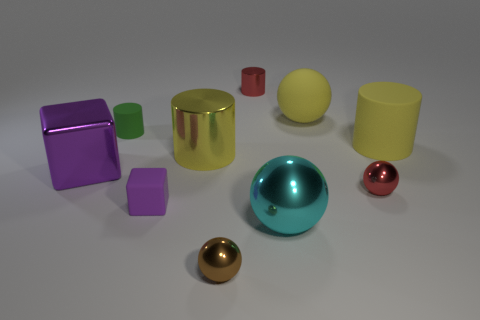There is a big yellow thing that is the same shape as the tiny brown thing; what material is it?
Your answer should be compact. Rubber. What shape is the yellow metal thing?
Ensure brevity in your answer.  Cylinder. The object that is to the right of the yellow matte ball and behind the big metal cylinder is made of what material?
Provide a short and direct response. Rubber. What shape is the large purple thing that is the same material as the cyan sphere?
Ensure brevity in your answer.  Cube. There is a purple thing that is the same material as the small brown object; what size is it?
Keep it short and to the point. Large. The rubber object that is in front of the big rubber ball and right of the yellow metal thing has what shape?
Make the answer very short. Cylinder. There is a metal cylinder in front of the big cylinder that is behind the yellow shiny object; how big is it?
Your answer should be very brief. Large. How many other things are the same color as the big cube?
Make the answer very short. 1. What is the tiny green object made of?
Keep it short and to the point. Rubber. Is there a small brown thing?
Give a very brief answer. Yes. 